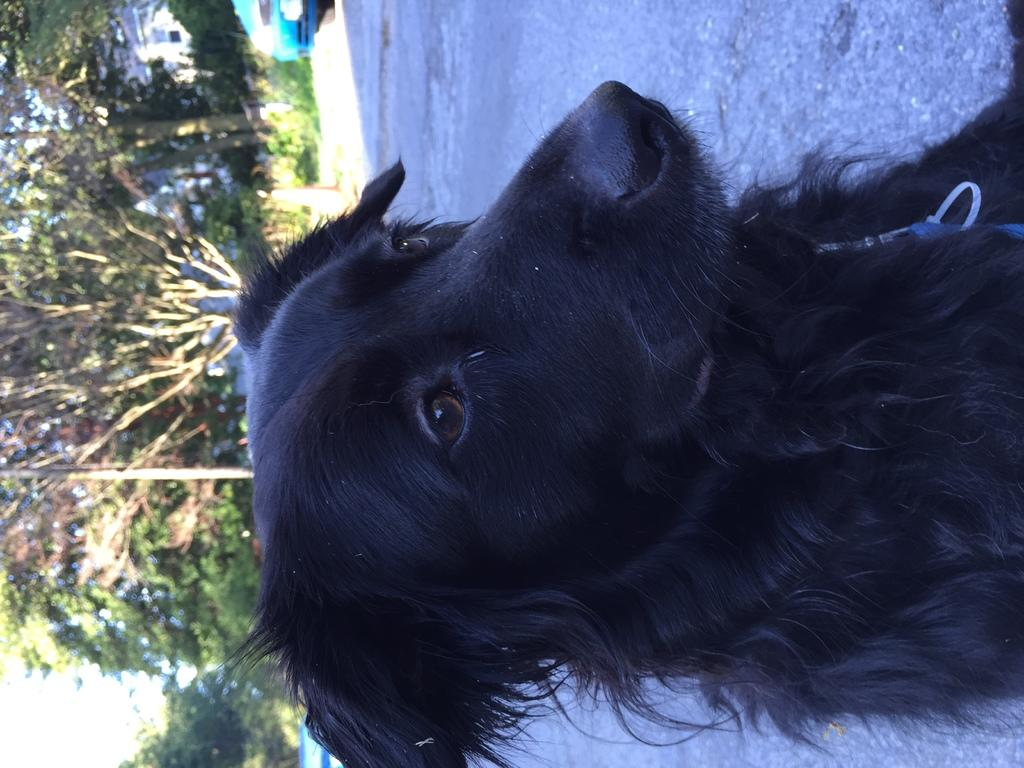What animal can be seen on the road in the image? There is a dog on the road in the image. What can be seen in the distance in the image? There is a vehicle in the background of the image. What object is present in the background of the image, near the vehicle? A traffic cone is present in the background of the image. What other objects can be seen in the background of the image? There is a pole and trees visible in the background of the image. What type of flowers can be seen growing along the coast in the image? There is no coast or flowers present in the image; it features a dog on the road, a vehicle, a traffic cone, a pole, and trees in the background. 